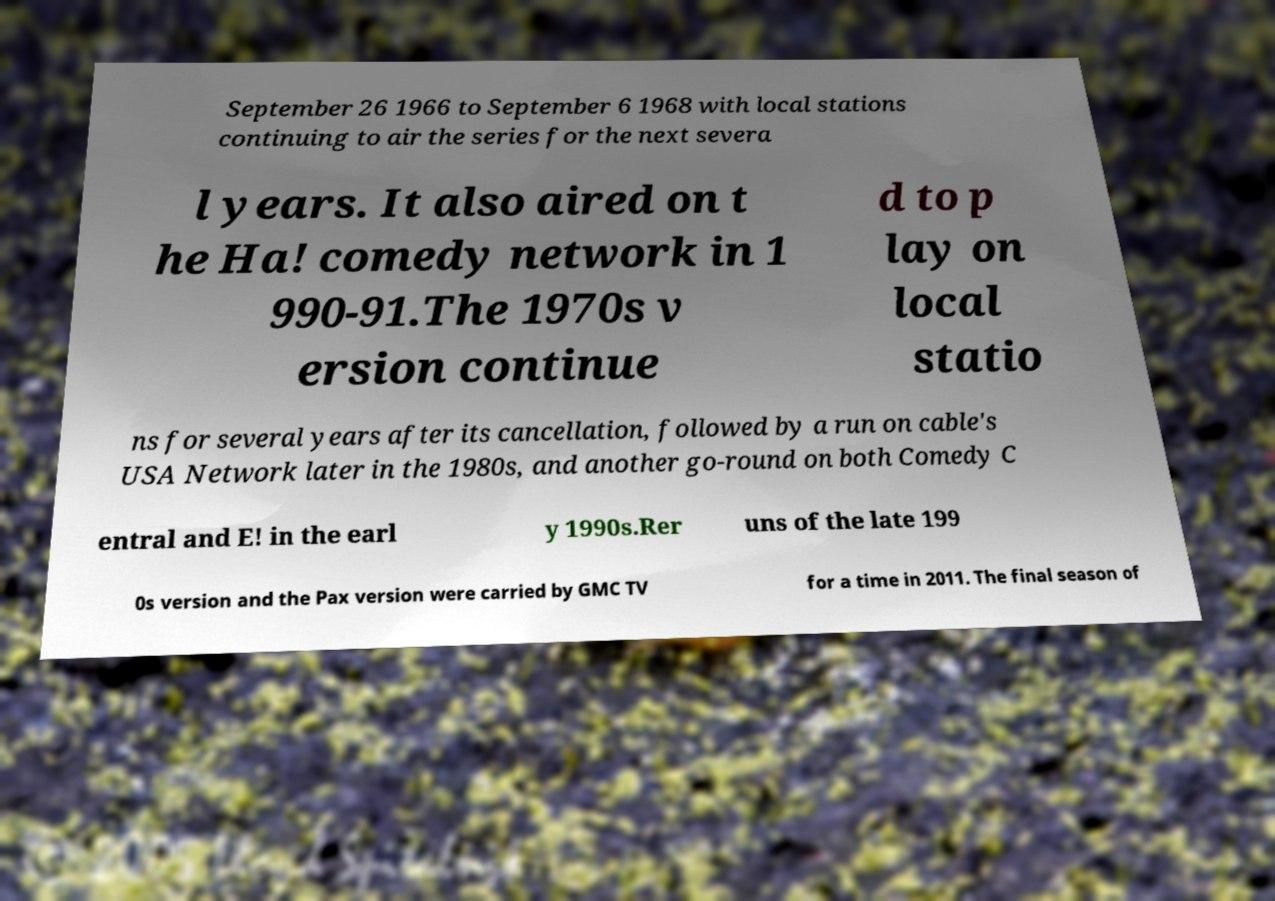For documentation purposes, I need the text within this image transcribed. Could you provide that? September 26 1966 to September 6 1968 with local stations continuing to air the series for the next severa l years. It also aired on t he Ha! comedy network in 1 990-91.The 1970s v ersion continue d to p lay on local statio ns for several years after its cancellation, followed by a run on cable's USA Network later in the 1980s, and another go-round on both Comedy C entral and E! in the earl y 1990s.Rer uns of the late 199 0s version and the Pax version were carried by GMC TV for a time in 2011. The final season of 